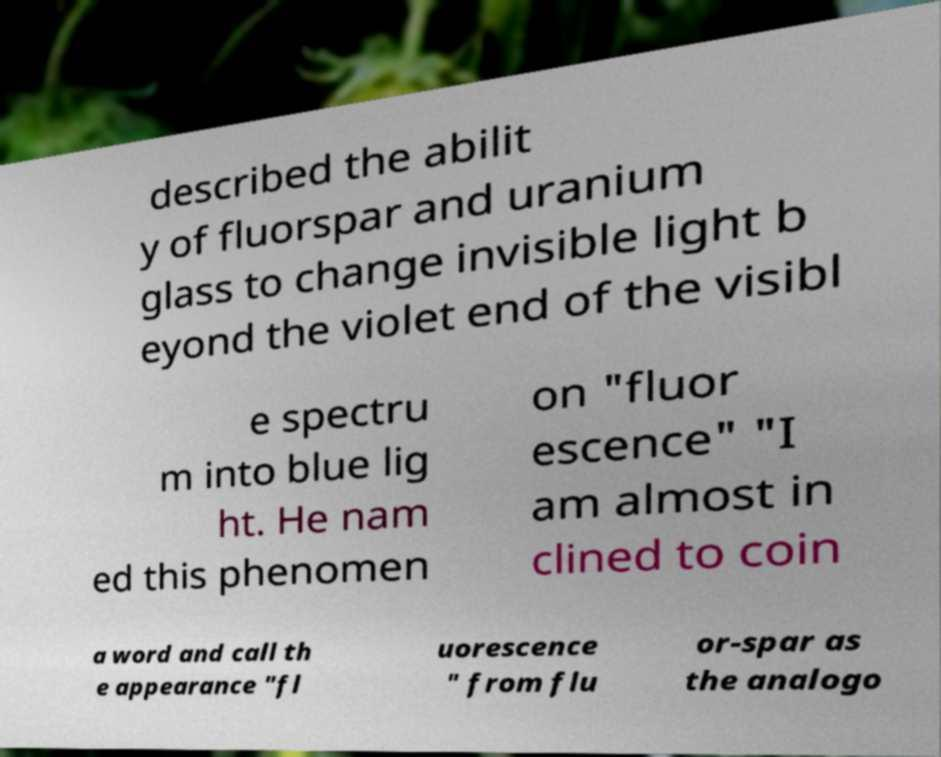Please identify and transcribe the text found in this image. described the abilit y of fluorspar and uranium glass to change invisible light b eyond the violet end of the visibl e spectru m into blue lig ht. He nam ed this phenomen on "fluor escence" "I am almost in clined to coin a word and call th e appearance "fl uorescence " from flu or-spar as the analogo 